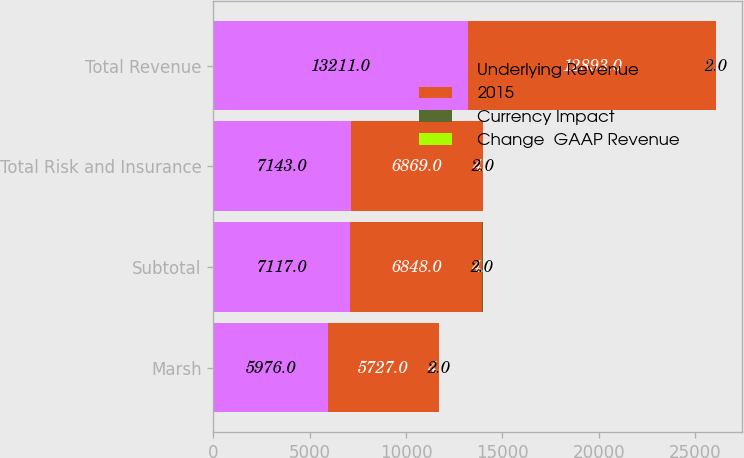Convert chart. <chart><loc_0><loc_0><loc_500><loc_500><stacked_bar_chart><ecel><fcel>Marsh<fcel>Subtotal<fcel>Total Risk and Insurance<fcel>Total Revenue<nl><fcel>Underlying Revenue<fcel>5976<fcel>7117<fcel>7143<fcel>13211<nl><fcel>2015<fcel>5727<fcel>6848<fcel>6869<fcel>12893<nl><fcel>Currency Impact<fcel>4<fcel>4<fcel>4<fcel>2<nl><fcel>Change  GAAP Revenue<fcel>2<fcel>2<fcel>2<fcel>2<nl></chart> 